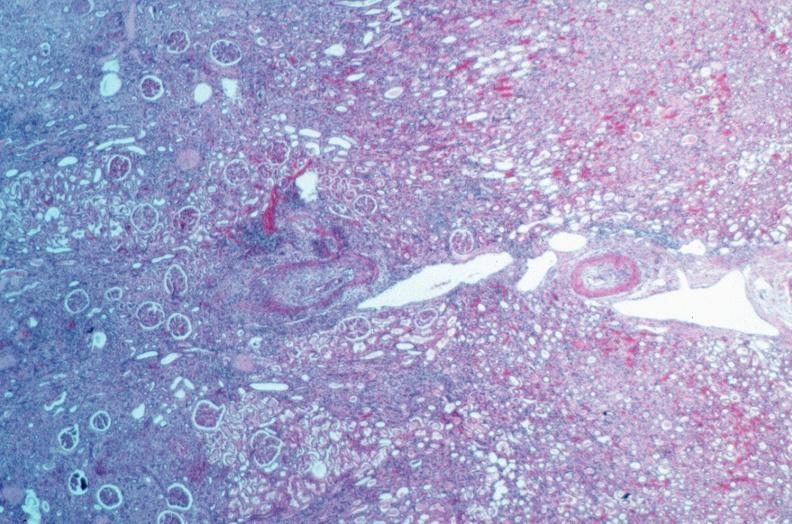where is this from?
Answer the question using a single word or phrase. Vasculature 